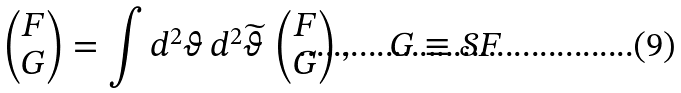Convert formula to latex. <formula><loc_0><loc_0><loc_500><loc_500>\begin{pmatrix} F \\ G \end{pmatrix} = \int d ^ { 2 } \vartheta \, d ^ { 2 } \widetilde { \vartheta } \, \begin{pmatrix} F \\ G \end{pmatrix} , \quad G \equiv \mathcal { S } F</formula> 